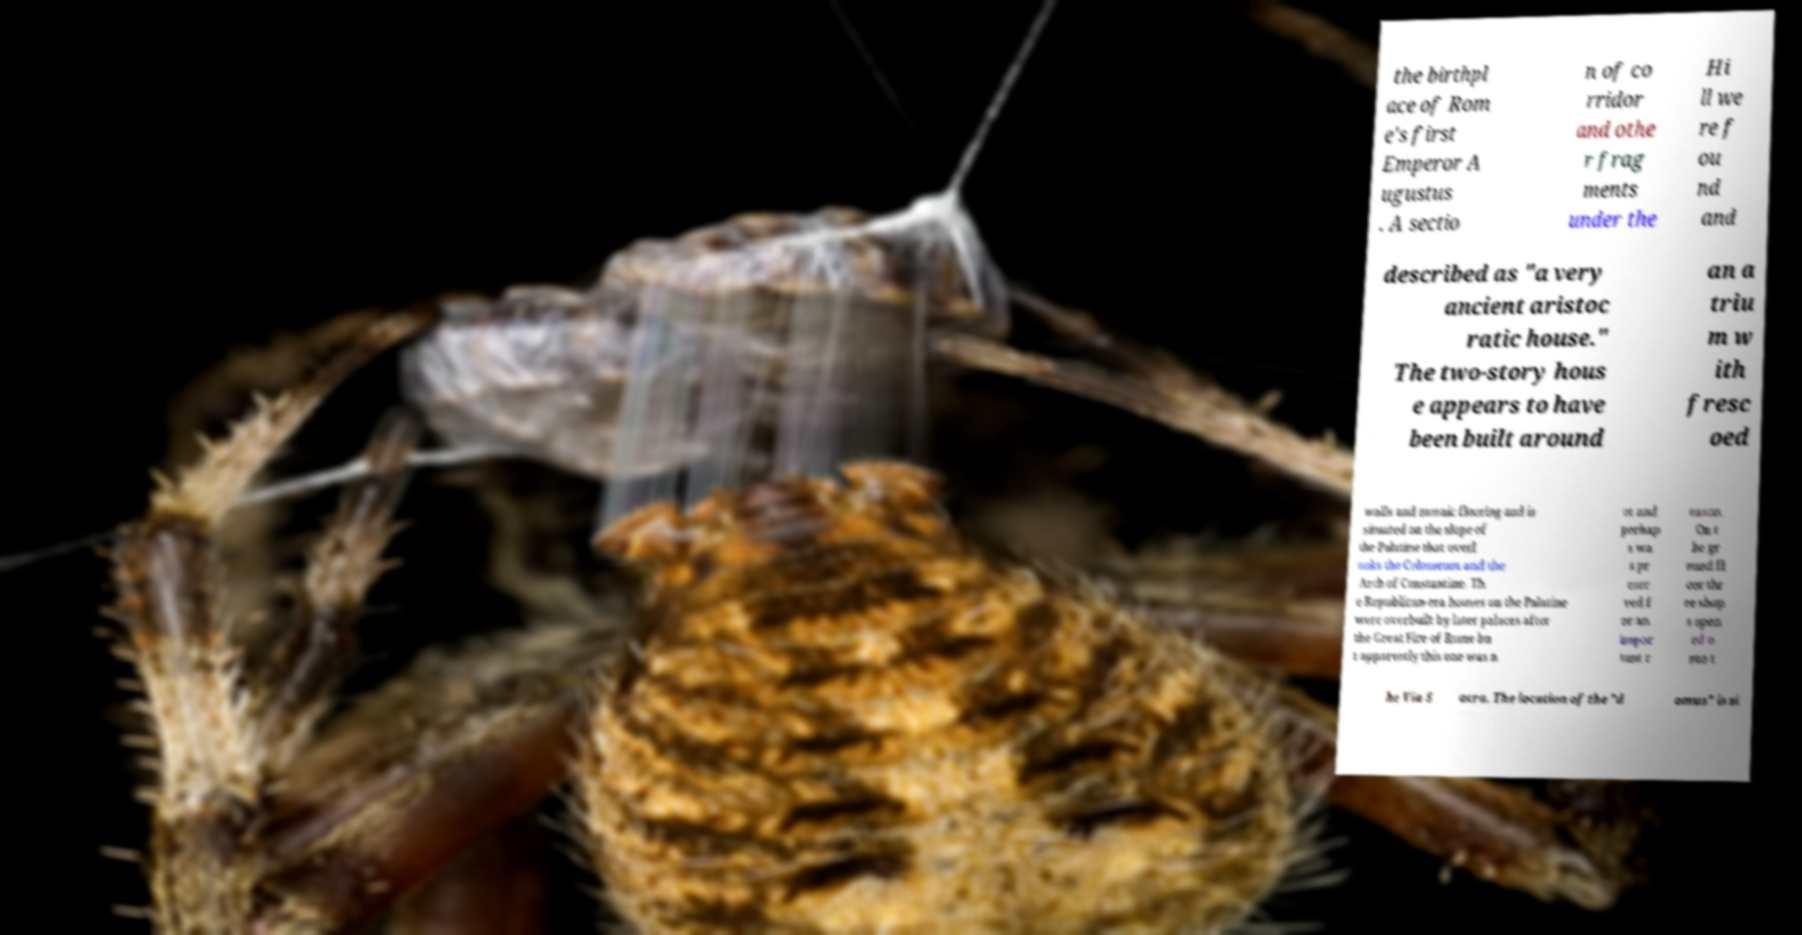What messages or text are displayed in this image? I need them in a readable, typed format. the birthpl ace of Rom e's first Emperor A ugustus . A sectio n of co rridor and othe r frag ments under the Hi ll we re f ou nd and described as "a very ancient aristoc ratic house." The two-story hous e appears to have been built around an a triu m w ith fresc oed walls and mosaic flooring and is situated on the slope of the Palatine that overl ooks the Colosseum and the Arch of Constantine. Th e Republican-era houses on the Palatine were overbuilt by later palaces after the Great Fire of Rome bu t apparently this one was n ot and perhap s wa s pr eser ved f or an impor tant r eason. On t he gr ound fl oor thr ee shop s open ed o nto t he Via S acra. The location of the "d omus" is si 